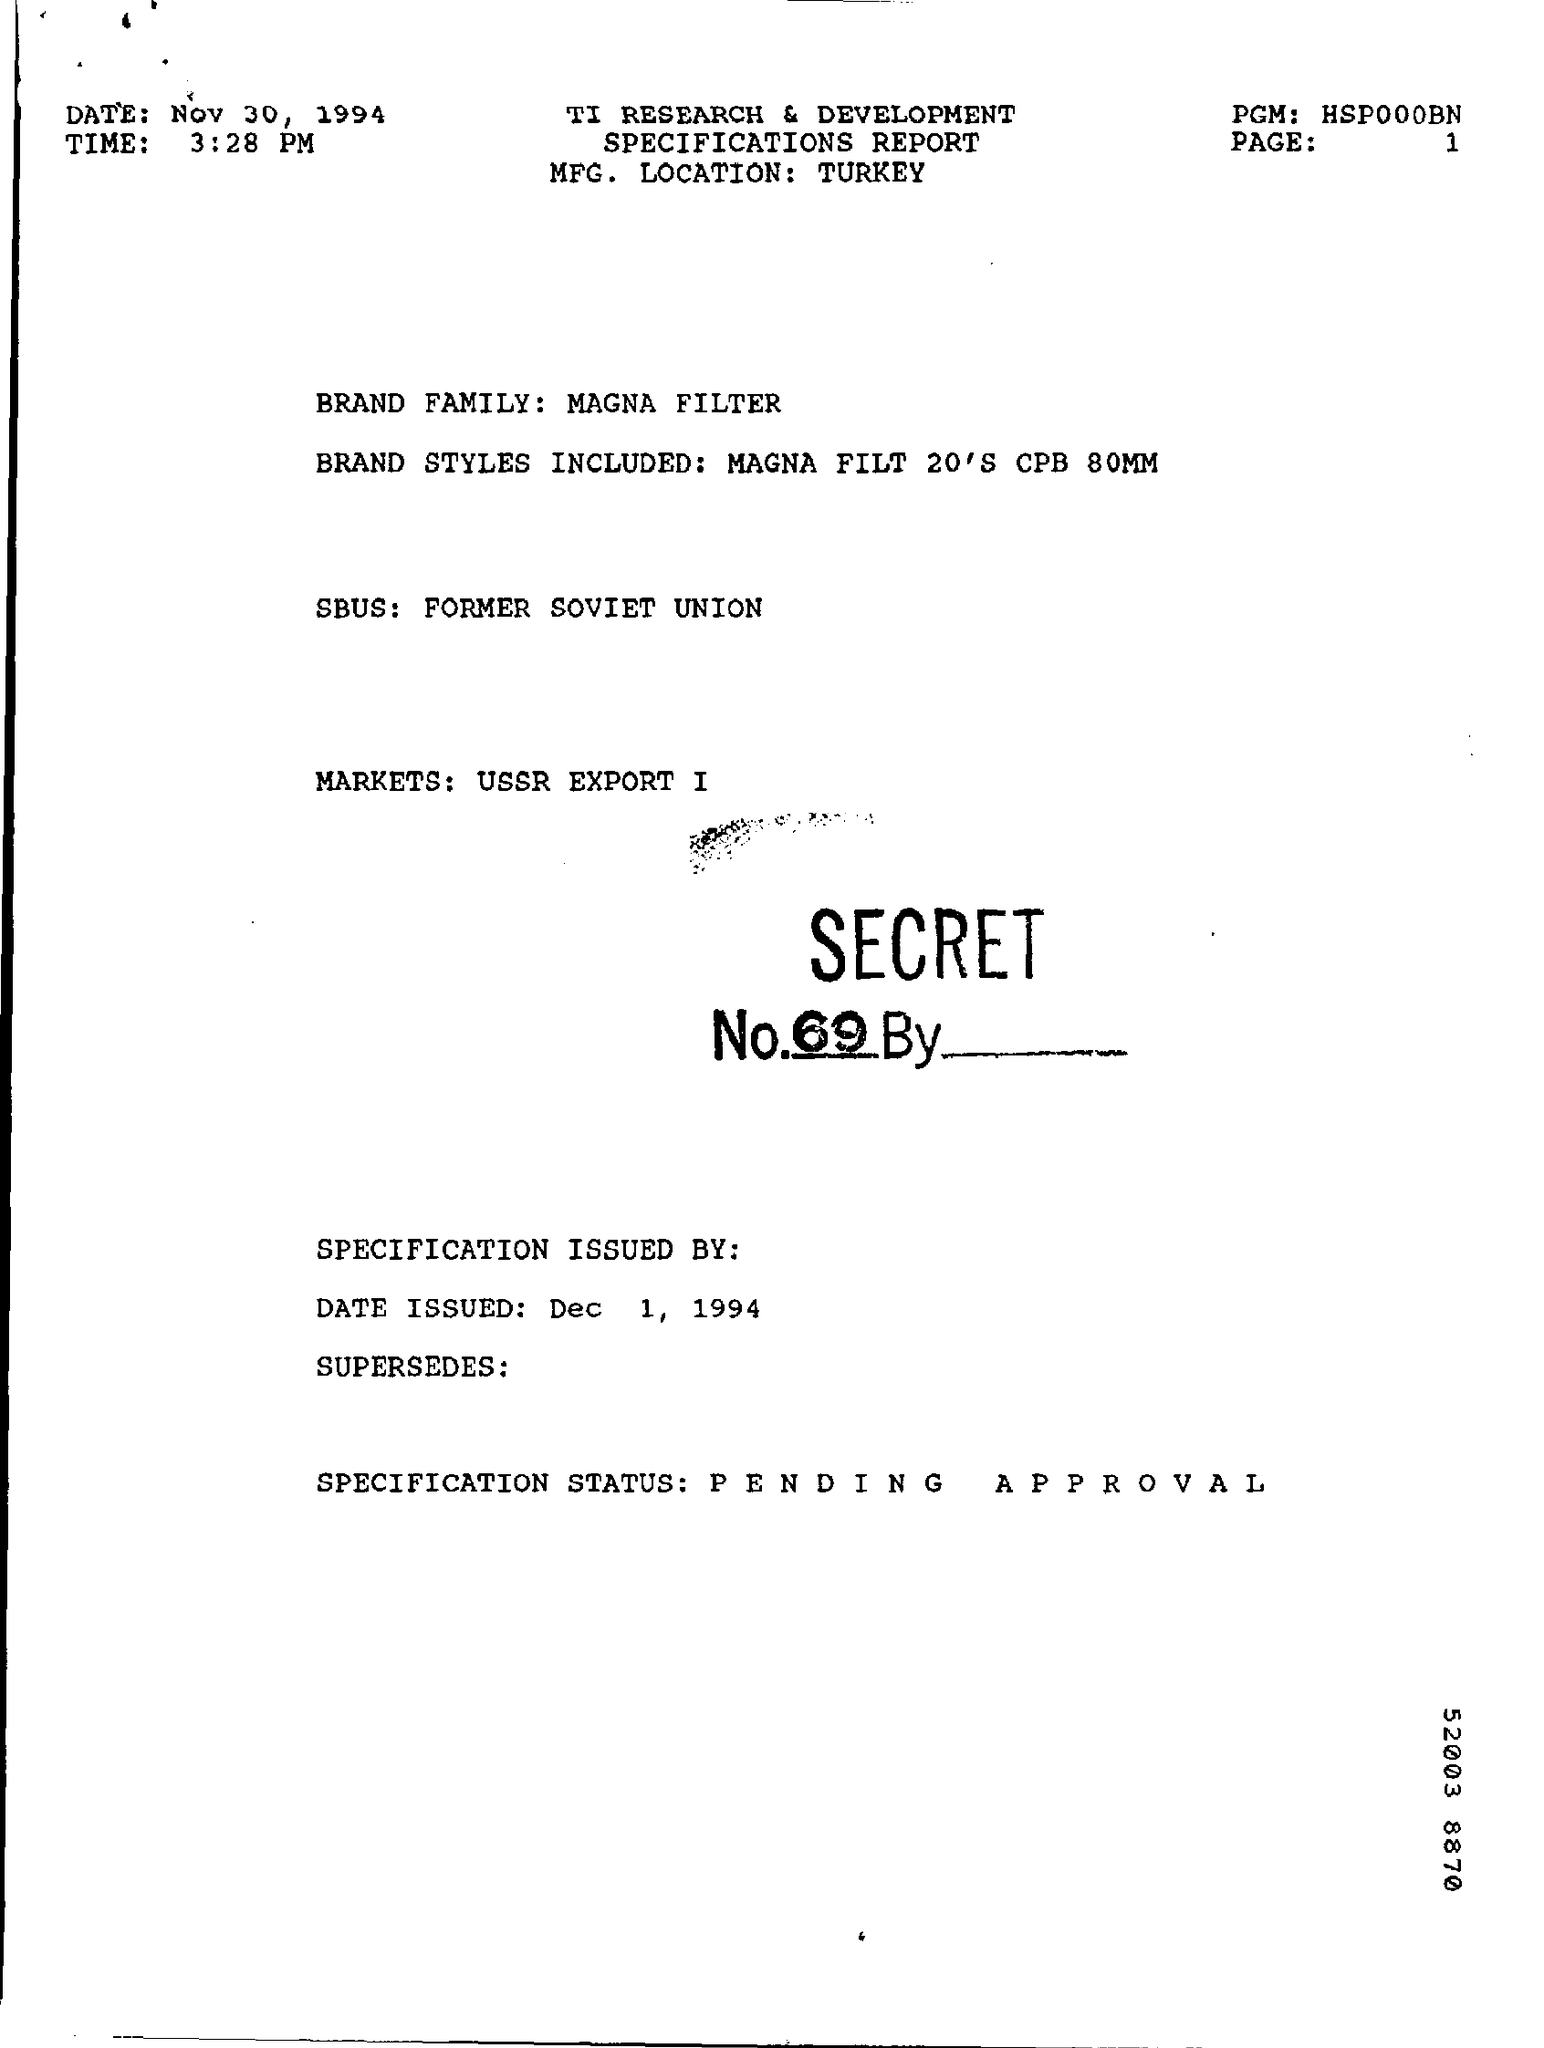Point out several critical features in this image. The time mentioned in the given report is 3:28 p.m. The report indicates that the specification status is currently pending approval. The given report includes information on various brand styles, such as Magna Filt 20, CPB 80mm, and others. According to the report, the brand family is named "Magna Filter. This report is prepared on the date of November 30, 1994. 